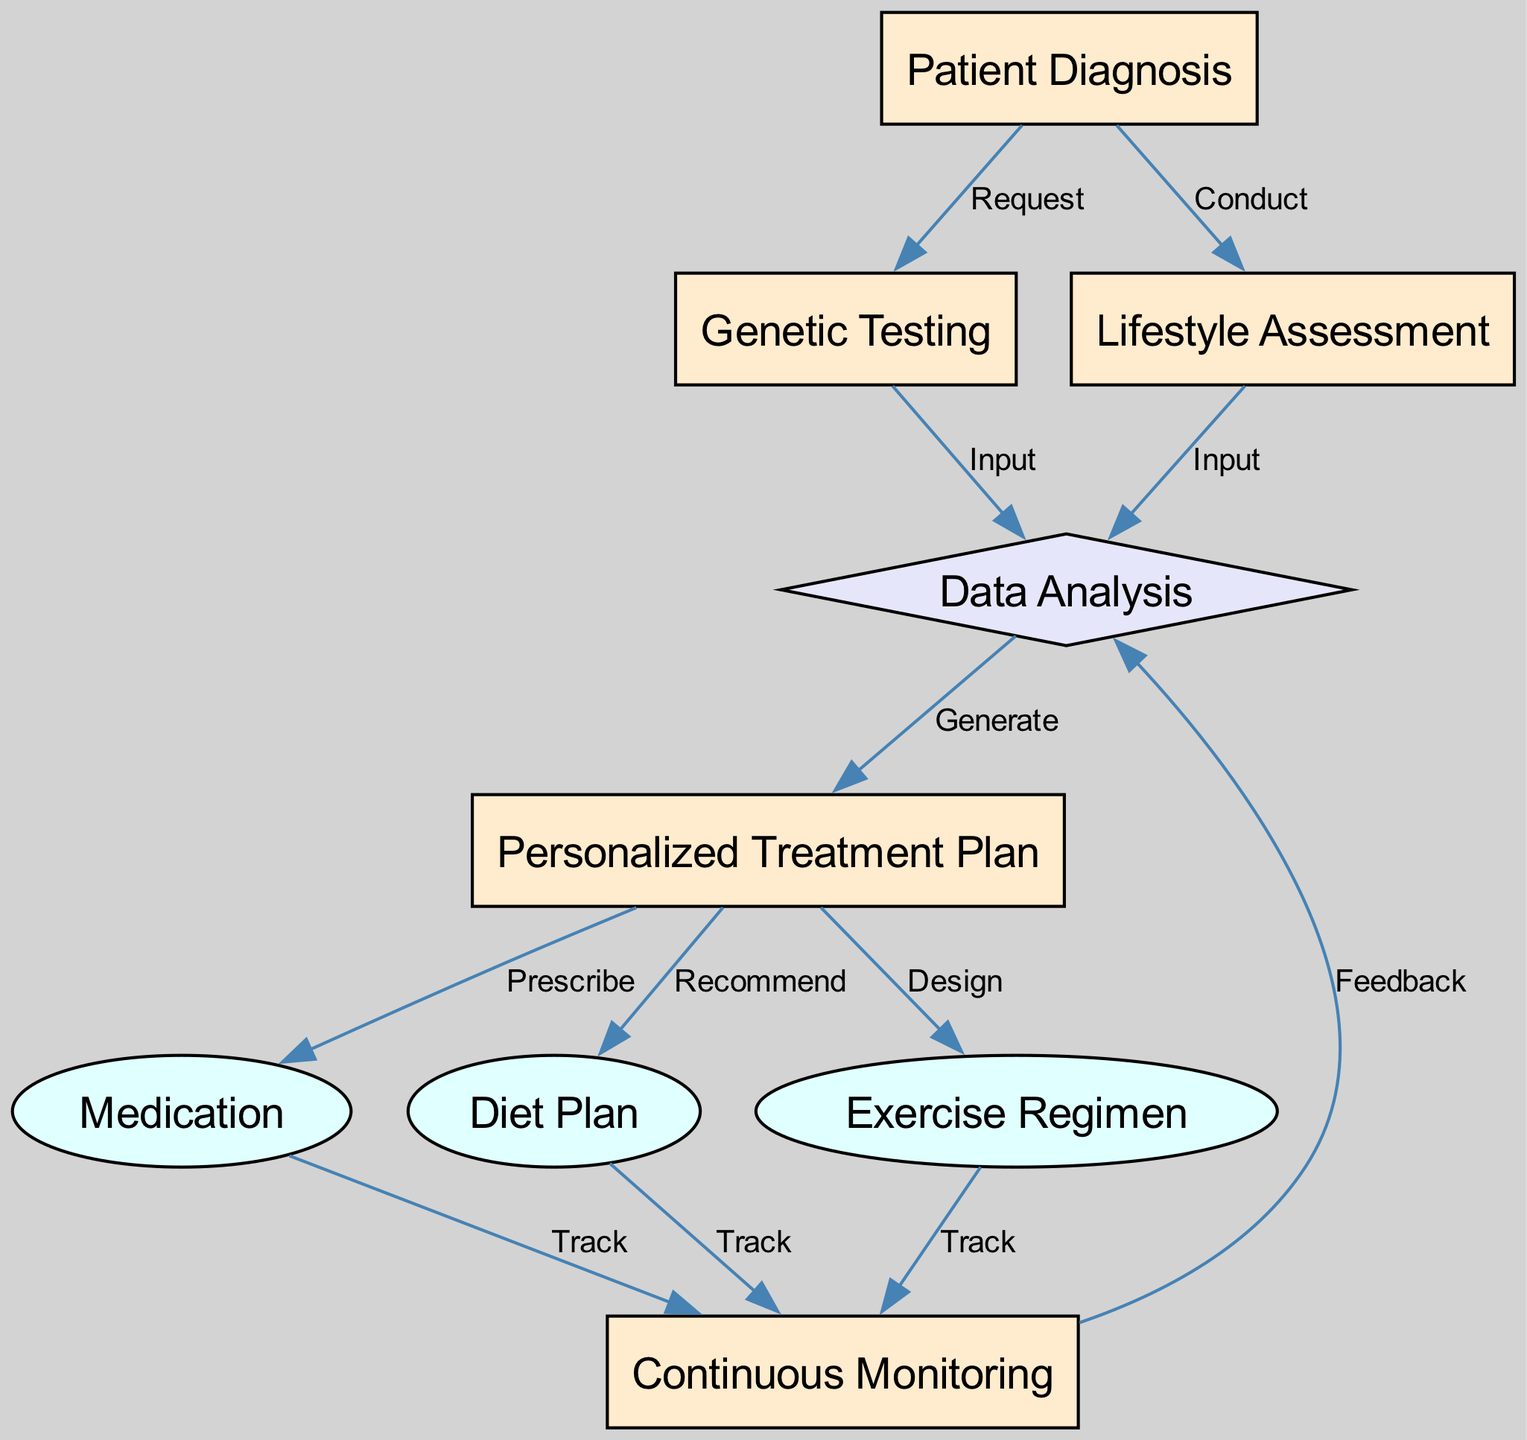What is the first step in the personalized medicine approach for diabetes management? The first step in the diagram is "Patient Diagnosis," which is indicated as the starting node in the flowchart. This is where the process begins before any testing or assessments are conducted.
Answer: Patient Diagnosis How many edges are leading out of the "Personalized Treatment Plan"? The "Personalized Treatment Plan" node has three edges leading out to "Medication," "Diet Plan," and "Exercise Regimen," as shown in the edges connecting to these nodes.
Answer: 3 What type of node is "Continuous Monitoring"? "Continuous Monitoring" is a rectangle node, which is indicated by the shape in the diagram representing it among the list of nodes with their respective shapes.
Answer: rectangle What is required to reach "Data Analysis" from both "Genetic Testing" and "Lifestyle Assessment"? To reach "Data Analysis," both "Genetic Testing" and "Lifestyle Assessment" provide their inputs, as indicated by the edges that show these relationships leading directly into the "Data Analysis" node.
Answer: Input List the outputs generated from the "Personalized Treatment Plan". The outputs generated are "Medication," "Diet Plan," and "Exercise Regimen," as indicated by the outgoing edges from the "Personalized Treatment Plan" leading to these three nodes.
Answer: Medication, Diet Plan, Exercise Regimen What relationship does “Continuous Monitoring” have with “Data Analysis”? "Continuous Monitoring" feeds back to "Data Analysis," as indicated by the edge connecting "Continuous Monitoring" to "Data Analysis," which represents a feedback loop in the process.
Answer: Feedback At what stage does the treatment plan get generated? The treatment plan gets generated at the "Data Analysis" stage, where all inputted data from genetic and lifestyle assessments is analyzed leading to the creation of the treatment plan.
Answer: Data Analysis What shape represents "Lifestyle Assessment" in the diagram? "Lifestyle Assessment" is represented as a rectangle in the diagram, which is consistent with the shape indicated for this node within the node's details.
Answer: rectangle How is "Exercise Regimen" related to "Continuous Monitoring"? "Exercise Regimen" is related to "Continuous Monitoring" through a "Track" edge that indicates the need for continuous tracking of the exercise regimen as part of diabetes management.
Answer: Track 